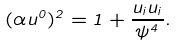<formula> <loc_0><loc_0><loc_500><loc_500>( \alpha u ^ { 0 } ) ^ { 2 } = 1 + \frac { u _ { i } u _ { i } } { \psi ^ { 4 } } .</formula> 